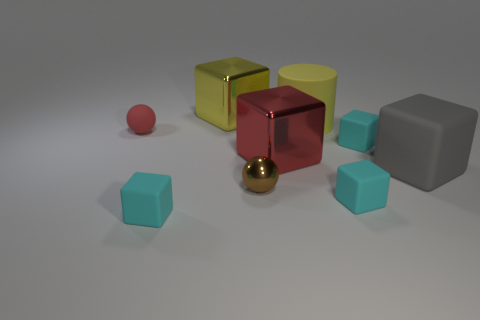Is there a big yellow thing?
Provide a short and direct response. Yes. Is the material of the cyan cube that is behind the brown metal ball the same as the gray thing?
Your answer should be very brief. Yes. What is the material of the other tiny thing that is the same shape as the small metallic thing?
Give a very brief answer. Rubber. What is the material of the thing that is the same color as the cylinder?
Provide a succinct answer. Metal. Is the number of tiny rubber blocks less than the number of large cylinders?
Offer a terse response. No. Is the color of the big cube that is behind the small red ball the same as the matte cylinder?
Offer a very short reply. Yes. What is the color of the large cube that is the same material as the large cylinder?
Your answer should be very brief. Gray. Is the size of the gray rubber thing the same as the brown metallic sphere?
Your answer should be compact. No. What is the yellow block made of?
Make the answer very short. Metal. What material is the red object that is the same size as the cylinder?
Ensure brevity in your answer.  Metal. 